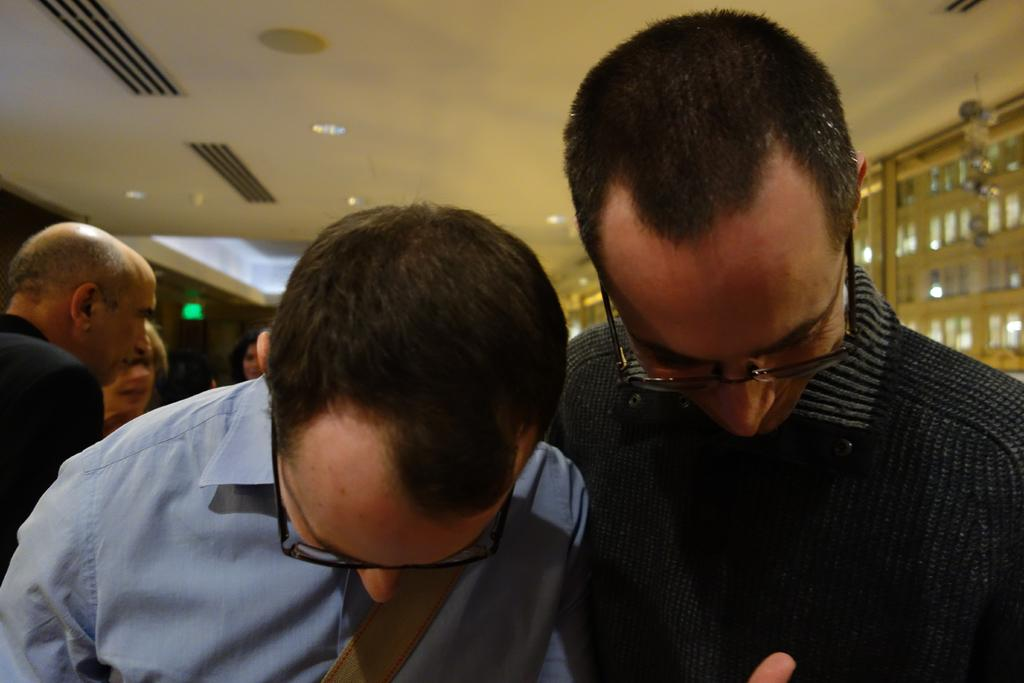How many people are the main focus of the image? There are two persons in the center of the image. What can be seen in the background of the image? There are people in the background of the image. What is visible at the top of the image? There is a ceiling with lights visible at the top of the image. What type of cloud can be seen in the image? There is no cloud visible in the image; it features a ceiling with lights. What kind of brush is being used by the person in the image? There is no brush present in the image. 